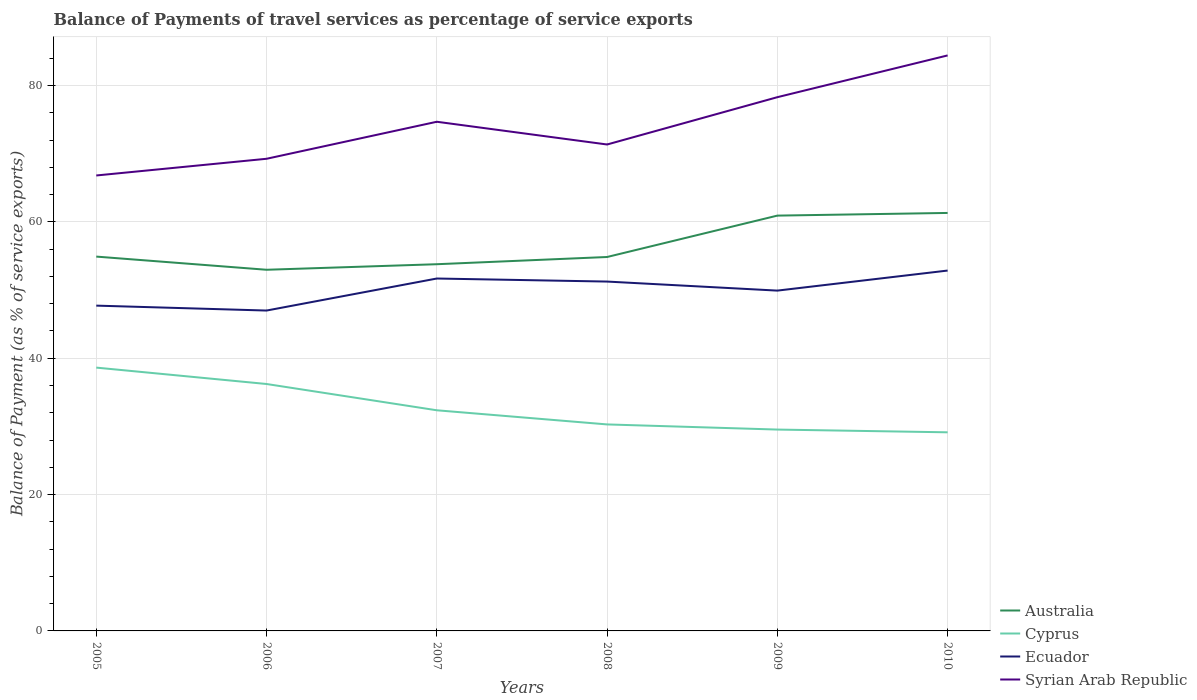Does the line corresponding to Cyprus intersect with the line corresponding to Ecuador?
Offer a very short reply. No. Across all years, what is the maximum balance of payments of travel services in Ecuador?
Make the answer very short. 46.99. What is the total balance of payments of travel services in Ecuador in the graph?
Your answer should be compact. -2.2. What is the difference between the highest and the second highest balance of payments of travel services in Ecuador?
Offer a very short reply. 5.87. What is the difference between the highest and the lowest balance of payments of travel services in Syrian Arab Republic?
Provide a short and direct response. 3. Is the balance of payments of travel services in Ecuador strictly greater than the balance of payments of travel services in Cyprus over the years?
Your answer should be compact. No. How many years are there in the graph?
Give a very brief answer. 6. Are the values on the major ticks of Y-axis written in scientific E-notation?
Offer a very short reply. No. Does the graph contain grids?
Your answer should be compact. Yes. Where does the legend appear in the graph?
Your response must be concise. Bottom right. What is the title of the graph?
Make the answer very short. Balance of Payments of travel services as percentage of service exports. Does "Upper middle income" appear as one of the legend labels in the graph?
Ensure brevity in your answer.  No. What is the label or title of the X-axis?
Your answer should be compact. Years. What is the label or title of the Y-axis?
Your answer should be compact. Balance of Payment (as % of service exports). What is the Balance of Payment (as % of service exports) in Australia in 2005?
Offer a very short reply. 54.91. What is the Balance of Payment (as % of service exports) of Cyprus in 2005?
Offer a very short reply. 38.62. What is the Balance of Payment (as % of service exports) of Ecuador in 2005?
Offer a terse response. 47.71. What is the Balance of Payment (as % of service exports) in Syrian Arab Republic in 2005?
Your answer should be compact. 66.8. What is the Balance of Payment (as % of service exports) of Australia in 2006?
Offer a terse response. 52.97. What is the Balance of Payment (as % of service exports) in Cyprus in 2006?
Give a very brief answer. 36.22. What is the Balance of Payment (as % of service exports) in Ecuador in 2006?
Provide a succinct answer. 46.99. What is the Balance of Payment (as % of service exports) of Syrian Arab Republic in 2006?
Provide a succinct answer. 69.25. What is the Balance of Payment (as % of service exports) of Australia in 2007?
Your answer should be compact. 53.79. What is the Balance of Payment (as % of service exports) of Cyprus in 2007?
Provide a succinct answer. 32.36. What is the Balance of Payment (as % of service exports) in Ecuador in 2007?
Ensure brevity in your answer.  51.69. What is the Balance of Payment (as % of service exports) of Syrian Arab Republic in 2007?
Keep it short and to the point. 74.68. What is the Balance of Payment (as % of service exports) of Australia in 2008?
Provide a short and direct response. 54.85. What is the Balance of Payment (as % of service exports) of Cyprus in 2008?
Your answer should be very brief. 30.29. What is the Balance of Payment (as % of service exports) in Ecuador in 2008?
Make the answer very short. 51.24. What is the Balance of Payment (as % of service exports) of Syrian Arab Republic in 2008?
Your answer should be compact. 71.35. What is the Balance of Payment (as % of service exports) in Australia in 2009?
Make the answer very short. 60.92. What is the Balance of Payment (as % of service exports) of Cyprus in 2009?
Ensure brevity in your answer.  29.53. What is the Balance of Payment (as % of service exports) of Ecuador in 2009?
Make the answer very short. 49.92. What is the Balance of Payment (as % of service exports) of Syrian Arab Republic in 2009?
Provide a short and direct response. 78.29. What is the Balance of Payment (as % of service exports) in Australia in 2010?
Your response must be concise. 61.31. What is the Balance of Payment (as % of service exports) of Cyprus in 2010?
Your answer should be compact. 29.13. What is the Balance of Payment (as % of service exports) in Ecuador in 2010?
Your answer should be compact. 52.86. What is the Balance of Payment (as % of service exports) in Syrian Arab Republic in 2010?
Offer a terse response. 84.41. Across all years, what is the maximum Balance of Payment (as % of service exports) in Australia?
Give a very brief answer. 61.31. Across all years, what is the maximum Balance of Payment (as % of service exports) of Cyprus?
Your response must be concise. 38.62. Across all years, what is the maximum Balance of Payment (as % of service exports) of Ecuador?
Offer a terse response. 52.86. Across all years, what is the maximum Balance of Payment (as % of service exports) in Syrian Arab Republic?
Your answer should be very brief. 84.41. Across all years, what is the minimum Balance of Payment (as % of service exports) of Australia?
Your answer should be compact. 52.97. Across all years, what is the minimum Balance of Payment (as % of service exports) of Cyprus?
Provide a succinct answer. 29.13. Across all years, what is the minimum Balance of Payment (as % of service exports) in Ecuador?
Provide a succinct answer. 46.99. Across all years, what is the minimum Balance of Payment (as % of service exports) of Syrian Arab Republic?
Your answer should be compact. 66.8. What is the total Balance of Payment (as % of service exports) in Australia in the graph?
Ensure brevity in your answer.  338.74. What is the total Balance of Payment (as % of service exports) in Cyprus in the graph?
Keep it short and to the point. 196.16. What is the total Balance of Payment (as % of service exports) of Ecuador in the graph?
Your answer should be compact. 300.41. What is the total Balance of Payment (as % of service exports) of Syrian Arab Republic in the graph?
Offer a very short reply. 444.79. What is the difference between the Balance of Payment (as % of service exports) in Australia in 2005 and that in 2006?
Give a very brief answer. 1.93. What is the difference between the Balance of Payment (as % of service exports) of Cyprus in 2005 and that in 2006?
Keep it short and to the point. 2.4. What is the difference between the Balance of Payment (as % of service exports) of Ecuador in 2005 and that in 2006?
Offer a very short reply. 0.72. What is the difference between the Balance of Payment (as % of service exports) in Syrian Arab Republic in 2005 and that in 2006?
Your answer should be very brief. -2.45. What is the difference between the Balance of Payment (as % of service exports) in Australia in 2005 and that in 2007?
Your response must be concise. 1.12. What is the difference between the Balance of Payment (as % of service exports) of Cyprus in 2005 and that in 2007?
Your response must be concise. 6.26. What is the difference between the Balance of Payment (as % of service exports) in Ecuador in 2005 and that in 2007?
Offer a terse response. -3.98. What is the difference between the Balance of Payment (as % of service exports) of Syrian Arab Republic in 2005 and that in 2007?
Give a very brief answer. -7.88. What is the difference between the Balance of Payment (as % of service exports) of Australia in 2005 and that in 2008?
Your answer should be very brief. 0.06. What is the difference between the Balance of Payment (as % of service exports) in Cyprus in 2005 and that in 2008?
Your answer should be compact. 8.33. What is the difference between the Balance of Payment (as % of service exports) in Ecuador in 2005 and that in 2008?
Make the answer very short. -3.53. What is the difference between the Balance of Payment (as % of service exports) of Syrian Arab Republic in 2005 and that in 2008?
Your answer should be compact. -4.54. What is the difference between the Balance of Payment (as % of service exports) in Australia in 2005 and that in 2009?
Offer a very short reply. -6.01. What is the difference between the Balance of Payment (as % of service exports) of Cyprus in 2005 and that in 2009?
Keep it short and to the point. 9.09. What is the difference between the Balance of Payment (as % of service exports) of Ecuador in 2005 and that in 2009?
Provide a succinct answer. -2.2. What is the difference between the Balance of Payment (as % of service exports) of Syrian Arab Republic in 2005 and that in 2009?
Provide a succinct answer. -11.48. What is the difference between the Balance of Payment (as % of service exports) in Australia in 2005 and that in 2010?
Your response must be concise. -6.41. What is the difference between the Balance of Payment (as % of service exports) of Cyprus in 2005 and that in 2010?
Offer a very short reply. 9.49. What is the difference between the Balance of Payment (as % of service exports) of Ecuador in 2005 and that in 2010?
Ensure brevity in your answer.  -5.14. What is the difference between the Balance of Payment (as % of service exports) in Syrian Arab Republic in 2005 and that in 2010?
Provide a short and direct response. -17.61. What is the difference between the Balance of Payment (as % of service exports) of Australia in 2006 and that in 2007?
Your response must be concise. -0.81. What is the difference between the Balance of Payment (as % of service exports) in Cyprus in 2006 and that in 2007?
Ensure brevity in your answer.  3.85. What is the difference between the Balance of Payment (as % of service exports) of Ecuador in 2006 and that in 2007?
Offer a terse response. -4.7. What is the difference between the Balance of Payment (as % of service exports) in Syrian Arab Republic in 2006 and that in 2007?
Provide a short and direct response. -5.43. What is the difference between the Balance of Payment (as % of service exports) of Australia in 2006 and that in 2008?
Provide a succinct answer. -1.87. What is the difference between the Balance of Payment (as % of service exports) in Cyprus in 2006 and that in 2008?
Provide a short and direct response. 5.93. What is the difference between the Balance of Payment (as % of service exports) of Ecuador in 2006 and that in 2008?
Provide a succinct answer. -4.25. What is the difference between the Balance of Payment (as % of service exports) in Syrian Arab Republic in 2006 and that in 2008?
Ensure brevity in your answer.  -2.09. What is the difference between the Balance of Payment (as % of service exports) of Australia in 2006 and that in 2009?
Make the answer very short. -7.94. What is the difference between the Balance of Payment (as % of service exports) of Cyprus in 2006 and that in 2009?
Offer a very short reply. 6.68. What is the difference between the Balance of Payment (as % of service exports) in Ecuador in 2006 and that in 2009?
Ensure brevity in your answer.  -2.92. What is the difference between the Balance of Payment (as % of service exports) of Syrian Arab Republic in 2006 and that in 2009?
Your answer should be very brief. -9.03. What is the difference between the Balance of Payment (as % of service exports) in Australia in 2006 and that in 2010?
Give a very brief answer. -8.34. What is the difference between the Balance of Payment (as % of service exports) of Cyprus in 2006 and that in 2010?
Make the answer very short. 7.09. What is the difference between the Balance of Payment (as % of service exports) of Ecuador in 2006 and that in 2010?
Your answer should be compact. -5.87. What is the difference between the Balance of Payment (as % of service exports) in Syrian Arab Republic in 2006 and that in 2010?
Give a very brief answer. -15.16. What is the difference between the Balance of Payment (as % of service exports) in Australia in 2007 and that in 2008?
Your answer should be compact. -1.06. What is the difference between the Balance of Payment (as % of service exports) of Cyprus in 2007 and that in 2008?
Provide a short and direct response. 2.07. What is the difference between the Balance of Payment (as % of service exports) of Ecuador in 2007 and that in 2008?
Provide a succinct answer. 0.45. What is the difference between the Balance of Payment (as % of service exports) in Syrian Arab Republic in 2007 and that in 2008?
Provide a succinct answer. 3.33. What is the difference between the Balance of Payment (as % of service exports) in Australia in 2007 and that in 2009?
Make the answer very short. -7.13. What is the difference between the Balance of Payment (as % of service exports) in Cyprus in 2007 and that in 2009?
Offer a very short reply. 2.83. What is the difference between the Balance of Payment (as % of service exports) of Ecuador in 2007 and that in 2009?
Make the answer very short. 1.77. What is the difference between the Balance of Payment (as % of service exports) in Syrian Arab Republic in 2007 and that in 2009?
Your answer should be very brief. -3.6. What is the difference between the Balance of Payment (as % of service exports) in Australia in 2007 and that in 2010?
Provide a succinct answer. -7.52. What is the difference between the Balance of Payment (as % of service exports) of Cyprus in 2007 and that in 2010?
Keep it short and to the point. 3.23. What is the difference between the Balance of Payment (as % of service exports) of Ecuador in 2007 and that in 2010?
Your answer should be very brief. -1.17. What is the difference between the Balance of Payment (as % of service exports) in Syrian Arab Republic in 2007 and that in 2010?
Your answer should be compact. -9.73. What is the difference between the Balance of Payment (as % of service exports) in Australia in 2008 and that in 2009?
Your response must be concise. -6.07. What is the difference between the Balance of Payment (as % of service exports) in Cyprus in 2008 and that in 2009?
Your answer should be compact. 0.75. What is the difference between the Balance of Payment (as % of service exports) of Ecuador in 2008 and that in 2009?
Your response must be concise. 1.33. What is the difference between the Balance of Payment (as % of service exports) of Syrian Arab Republic in 2008 and that in 2009?
Ensure brevity in your answer.  -6.94. What is the difference between the Balance of Payment (as % of service exports) of Australia in 2008 and that in 2010?
Provide a short and direct response. -6.46. What is the difference between the Balance of Payment (as % of service exports) of Cyprus in 2008 and that in 2010?
Your answer should be very brief. 1.16. What is the difference between the Balance of Payment (as % of service exports) of Ecuador in 2008 and that in 2010?
Your response must be concise. -1.61. What is the difference between the Balance of Payment (as % of service exports) of Syrian Arab Republic in 2008 and that in 2010?
Ensure brevity in your answer.  -13.07. What is the difference between the Balance of Payment (as % of service exports) of Australia in 2009 and that in 2010?
Make the answer very short. -0.39. What is the difference between the Balance of Payment (as % of service exports) of Cyprus in 2009 and that in 2010?
Your answer should be very brief. 0.4. What is the difference between the Balance of Payment (as % of service exports) of Ecuador in 2009 and that in 2010?
Offer a very short reply. -2.94. What is the difference between the Balance of Payment (as % of service exports) in Syrian Arab Republic in 2009 and that in 2010?
Offer a very short reply. -6.13. What is the difference between the Balance of Payment (as % of service exports) in Australia in 2005 and the Balance of Payment (as % of service exports) in Cyprus in 2006?
Your response must be concise. 18.69. What is the difference between the Balance of Payment (as % of service exports) of Australia in 2005 and the Balance of Payment (as % of service exports) of Ecuador in 2006?
Keep it short and to the point. 7.91. What is the difference between the Balance of Payment (as % of service exports) in Australia in 2005 and the Balance of Payment (as % of service exports) in Syrian Arab Republic in 2006?
Ensure brevity in your answer.  -14.35. What is the difference between the Balance of Payment (as % of service exports) in Cyprus in 2005 and the Balance of Payment (as % of service exports) in Ecuador in 2006?
Provide a succinct answer. -8.37. What is the difference between the Balance of Payment (as % of service exports) of Cyprus in 2005 and the Balance of Payment (as % of service exports) of Syrian Arab Republic in 2006?
Offer a terse response. -30.63. What is the difference between the Balance of Payment (as % of service exports) in Ecuador in 2005 and the Balance of Payment (as % of service exports) in Syrian Arab Republic in 2006?
Ensure brevity in your answer.  -21.54. What is the difference between the Balance of Payment (as % of service exports) in Australia in 2005 and the Balance of Payment (as % of service exports) in Cyprus in 2007?
Offer a very short reply. 22.54. What is the difference between the Balance of Payment (as % of service exports) in Australia in 2005 and the Balance of Payment (as % of service exports) in Ecuador in 2007?
Give a very brief answer. 3.22. What is the difference between the Balance of Payment (as % of service exports) of Australia in 2005 and the Balance of Payment (as % of service exports) of Syrian Arab Republic in 2007?
Offer a very short reply. -19.78. What is the difference between the Balance of Payment (as % of service exports) of Cyprus in 2005 and the Balance of Payment (as % of service exports) of Ecuador in 2007?
Your response must be concise. -13.07. What is the difference between the Balance of Payment (as % of service exports) of Cyprus in 2005 and the Balance of Payment (as % of service exports) of Syrian Arab Republic in 2007?
Your answer should be very brief. -36.06. What is the difference between the Balance of Payment (as % of service exports) of Ecuador in 2005 and the Balance of Payment (as % of service exports) of Syrian Arab Republic in 2007?
Keep it short and to the point. -26.97. What is the difference between the Balance of Payment (as % of service exports) of Australia in 2005 and the Balance of Payment (as % of service exports) of Cyprus in 2008?
Your answer should be very brief. 24.62. What is the difference between the Balance of Payment (as % of service exports) in Australia in 2005 and the Balance of Payment (as % of service exports) in Ecuador in 2008?
Ensure brevity in your answer.  3.66. What is the difference between the Balance of Payment (as % of service exports) in Australia in 2005 and the Balance of Payment (as % of service exports) in Syrian Arab Republic in 2008?
Your response must be concise. -16.44. What is the difference between the Balance of Payment (as % of service exports) of Cyprus in 2005 and the Balance of Payment (as % of service exports) of Ecuador in 2008?
Your response must be concise. -12.62. What is the difference between the Balance of Payment (as % of service exports) of Cyprus in 2005 and the Balance of Payment (as % of service exports) of Syrian Arab Republic in 2008?
Your response must be concise. -32.73. What is the difference between the Balance of Payment (as % of service exports) in Ecuador in 2005 and the Balance of Payment (as % of service exports) in Syrian Arab Republic in 2008?
Give a very brief answer. -23.63. What is the difference between the Balance of Payment (as % of service exports) in Australia in 2005 and the Balance of Payment (as % of service exports) in Cyprus in 2009?
Keep it short and to the point. 25.37. What is the difference between the Balance of Payment (as % of service exports) of Australia in 2005 and the Balance of Payment (as % of service exports) of Ecuador in 2009?
Your answer should be compact. 4.99. What is the difference between the Balance of Payment (as % of service exports) in Australia in 2005 and the Balance of Payment (as % of service exports) in Syrian Arab Republic in 2009?
Ensure brevity in your answer.  -23.38. What is the difference between the Balance of Payment (as % of service exports) of Cyprus in 2005 and the Balance of Payment (as % of service exports) of Ecuador in 2009?
Provide a short and direct response. -11.29. What is the difference between the Balance of Payment (as % of service exports) of Cyprus in 2005 and the Balance of Payment (as % of service exports) of Syrian Arab Republic in 2009?
Give a very brief answer. -39.67. What is the difference between the Balance of Payment (as % of service exports) in Ecuador in 2005 and the Balance of Payment (as % of service exports) in Syrian Arab Republic in 2009?
Give a very brief answer. -30.57. What is the difference between the Balance of Payment (as % of service exports) of Australia in 2005 and the Balance of Payment (as % of service exports) of Cyprus in 2010?
Provide a succinct answer. 25.77. What is the difference between the Balance of Payment (as % of service exports) in Australia in 2005 and the Balance of Payment (as % of service exports) in Ecuador in 2010?
Ensure brevity in your answer.  2.05. What is the difference between the Balance of Payment (as % of service exports) in Australia in 2005 and the Balance of Payment (as % of service exports) in Syrian Arab Republic in 2010?
Provide a succinct answer. -29.51. What is the difference between the Balance of Payment (as % of service exports) of Cyprus in 2005 and the Balance of Payment (as % of service exports) of Ecuador in 2010?
Offer a terse response. -14.24. What is the difference between the Balance of Payment (as % of service exports) of Cyprus in 2005 and the Balance of Payment (as % of service exports) of Syrian Arab Republic in 2010?
Give a very brief answer. -45.79. What is the difference between the Balance of Payment (as % of service exports) of Ecuador in 2005 and the Balance of Payment (as % of service exports) of Syrian Arab Republic in 2010?
Give a very brief answer. -36.7. What is the difference between the Balance of Payment (as % of service exports) in Australia in 2006 and the Balance of Payment (as % of service exports) in Cyprus in 2007?
Make the answer very short. 20.61. What is the difference between the Balance of Payment (as % of service exports) in Australia in 2006 and the Balance of Payment (as % of service exports) in Ecuador in 2007?
Provide a succinct answer. 1.28. What is the difference between the Balance of Payment (as % of service exports) of Australia in 2006 and the Balance of Payment (as % of service exports) of Syrian Arab Republic in 2007?
Keep it short and to the point. -21.71. What is the difference between the Balance of Payment (as % of service exports) in Cyprus in 2006 and the Balance of Payment (as % of service exports) in Ecuador in 2007?
Offer a terse response. -15.47. What is the difference between the Balance of Payment (as % of service exports) in Cyprus in 2006 and the Balance of Payment (as % of service exports) in Syrian Arab Republic in 2007?
Give a very brief answer. -38.46. What is the difference between the Balance of Payment (as % of service exports) of Ecuador in 2006 and the Balance of Payment (as % of service exports) of Syrian Arab Republic in 2007?
Give a very brief answer. -27.69. What is the difference between the Balance of Payment (as % of service exports) in Australia in 2006 and the Balance of Payment (as % of service exports) in Cyprus in 2008?
Your response must be concise. 22.68. What is the difference between the Balance of Payment (as % of service exports) of Australia in 2006 and the Balance of Payment (as % of service exports) of Ecuador in 2008?
Offer a terse response. 1.73. What is the difference between the Balance of Payment (as % of service exports) in Australia in 2006 and the Balance of Payment (as % of service exports) in Syrian Arab Republic in 2008?
Make the answer very short. -18.37. What is the difference between the Balance of Payment (as % of service exports) in Cyprus in 2006 and the Balance of Payment (as % of service exports) in Ecuador in 2008?
Provide a succinct answer. -15.02. What is the difference between the Balance of Payment (as % of service exports) of Cyprus in 2006 and the Balance of Payment (as % of service exports) of Syrian Arab Republic in 2008?
Your answer should be compact. -35.13. What is the difference between the Balance of Payment (as % of service exports) in Ecuador in 2006 and the Balance of Payment (as % of service exports) in Syrian Arab Republic in 2008?
Provide a succinct answer. -24.36. What is the difference between the Balance of Payment (as % of service exports) of Australia in 2006 and the Balance of Payment (as % of service exports) of Cyprus in 2009?
Provide a short and direct response. 23.44. What is the difference between the Balance of Payment (as % of service exports) in Australia in 2006 and the Balance of Payment (as % of service exports) in Ecuador in 2009?
Make the answer very short. 3.06. What is the difference between the Balance of Payment (as % of service exports) of Australia in 2006 and the Balance of Payment (as % of service exports) of Syrian Arab Republic in 2009?
Your answer should be very brief. -25.31. What is the difference between the Balance of Payment (as % of service exports) in Cyprus in 2006 and the Balance of Payment (as % of service exports) in Ecuador in 2009?
Your response must be concise. -13.7. What is the difference between the Balance of Payment (as % of service exports) in Cyprus in 2006 and the Balance of Payment (as % of service exports) in Syrian Arab Republic in 2009?
Your answer should be compact. -42.07. What is the difference between the Balance of Payment (as % of service exports) of Ecuador in 2006 and the Balance of Payment (as % of service exports) of Syrian Arab Republic in 2009?
Your answer should be compact. -31.3. What is the difference between the Balance of Payment (as % of service exports) in Australia in 2006 and the Balance of Payment (as % of service exports) in Cyprus in 2010?
Your answer should be very brief. 23.84. What is the difference between the Balance of Payment (as % of service exports) in Australia in 2006 and the Balance of Payment (as % of service exports) in Ecuador in 2010?
Your response must be concise. 0.12. What is the difference between the Balance of Payment (as % of service exports) in Australia in 2006 and the Balance of Payment (as % of service exports) in Syrian Arab Republic in 2010?
Keep it short and to the point. -31.44. What is the difference between the Balance of Payment (as % of service exports) of Cyprus in 2006 and the Balance of Payment (as % of service exports) of Ecuador in 2010?
Make the answer very short. -16.64. What is the difference between the Balance of Payment (as % of service exports) in Cyprus in 2006 and the Balance of Payment (as % of service exports) in Syrian Arab Republic in 2010?
Offer a very short reply. -48.2. What is the difference between the Balance of Payment (as % of service exports) of Ecuador in 2006 and the Balance of Payment (as % of service exports) of Syrian Arab Republic in 2010?
Make the answer very short. -37.42. What is the difference between the Balance of Payment (as % of service exports) of Australia in 2007 and the Balance of Payment (as % of service exports) of Cyprus in 2008?
Ensure brevity in your answer.  23.5. What is the difference between the Balance of Payment (as % of service exports) in Australia in 2007 and the Balance of Payment (as % of service exports) in Ecuador in 2008?
Keep it short and to the point. 2.54. What is the difference between the Balance of Payment (as % of service exports) in Australia in 2007 and the Balance of Payment (as % of service exports) in Syrian Arab Republic in 2008?
Offer a terse response. -17.56. What is the difference between the Balance of Payment (as % of service exports) in Cyprus in 2007 and the Balance of Payment (as % of service exports) in Ecuador in 2008?
Keep it short and to the point. -18.88. What is the difference between the Balance of Payment (as % of service exports) in Cyprus in 2007 and the Balance of Payment (as % of service exports) in Syrian Arab Republic in 2008?
Make the answer very short. -38.98. What is the difference between the Balance of Payment (as % of service exports) in Ecuador in 2007 and the Balance of Payment (as % of service exports) in Syrian Arab Republic in 2008?
Make the answer very short. -19.66. What is the difference between the Balance of Payment (as % of service exports) of Australia in 2007 and the Balance of Payment (as % of service exports) of Cyprus in 2009?
Give a very brief answer. 24.25. What is the difference between the Balance of Payment (as % of service exports) of Australia in 2007 and the Balance of Payment (as % of service exports) of Ecuador in 2009?
Provide a succinct answer. 3.87. What is the difference between the Balance of Payment (as % of service exports) of Australia in 2007 and the Balance of Payment (as % of service exports) of Syrian Arab Republic in 2009?
Keep it short and to the point. -24.5. What is the difference between the Balance of Payment (as % of service exports) in Cyprus in 2007 and the Balance of Payment (as % of service exports) in Ecuador in 2009?
Your answer should be very brief. -17.55. What is the difference between the Balance of Payment (as % of service exports) in Cyprus in 2007 and the Balance of Payment (as % of service exports) in Syrian Arab Republic in 2009?
Offer a very short reply. -45.92. What is the difference between the Balance of Payment (as % of service exports) of Ecuador in 2007 and the Balance of Payment (as % of service exports) of Syrian Arab Republic in 2009?
Your answer should be very brief. -26.6. What is the difference between the Balance of Payment (as % of service exports) of Australia in 2007 and the Balance of Payment (as % of service exports) of Cyprus in 2010?
Offer a very short reply. 24.66. What is the difference between the Balance of Payment (as % of service exports) of Australia in 2007 and the Balance of Payment (as % of service exports) of Ecuador in 2010?
Offer a very short reply. 0.93. What is the difference between the Balance of Payment (as % of service exports) in Australia in 2007 and the Balance of Payment (as % of service exports) in Syrian Arab Republic in 2010?
Provide a short and direct response. -30.63. What is the difference between the Balance of Payment (as % of service exports) in Cyprus in 2007 and the Balance of Payment (as % of service exports) in Ecuador in 2010?
Offer a terse response. -20.49. What is the difference between the Balance of Payment (as % of service exports) in Cyprus in 2007 and the Balance of Payment (as % of service exports) in Syrian Arab Republic in 2010?
Your response must be concise. -52.05. What is the difference between the Balance of Payment (as % of service exports) in Ecuador in 2007 and the Balance of Payment (as % of service exports) in Syrian Arab Republic in 2010?
Provide a succinct answer. -32.72. What is the difference between the Balance of Payment (as % of service exports) of Australia in 2008 and the Balance of Payment (as % of service exports) of Cyprus in 2009?
Your answer should be very brief. 25.31. What is the difference between the Balance of Payment (as % of service exports) in Australia in 2008 and the Balance of Payment (as % of service exports) in Ecuador in 2009?
Keep it short and to the point. 4.93. What is the difference between the Balance of Payment (as % of service exports) in Australia in 2008 and the Balance of Payment (as % of service exports) in Syrian Arab Republic in 2009?
Give a very brief answer. -23.44. What is the difference between the Balance of Payment (as % of service exports) of Cyprus in 2008 and the Balance of Payment (as % of service exports) of Ecuador in 2009?
Provide a succinct answer. -19.63. What is the difference between the Balance of Payment (as % of service exports) in Cyprus in 2008 and the Balance of Payment (as % of service exports) in Syrian Arab Republic in 2009?
Your answer should be very brief. -48. What is the difference between the Balance of Payment (as % of service exports) of Ecuador in 2008 and the Balance of Payment (as % of service exports) of Syrian Arab Republic in 2009?
Offer a terse response. -27.04. What is the difference between the Balance of Payment (as % of service exports) in Australia in 2008 and the Balance of Payment (as % of service exports) in Cyprus in 2010?
Your answer should be compact. 25.71. What is the difference between the Balance of Payment (as % of service exports) of Australia in 2008 and the Balance of Payment (as % of service exports) of Ecuador in 2010?
Your response must be concise. 1.99. What is the difference between the Balance of Payment (as % of service exports) of Australia in 2008 and the Balance of Payment (as % of service exports) of Syrian Arab Republic in 2010?
Offer a very short reply. -29.57. What is the difference between the Balance of Payment (as % of service exports) in Cyprus in 2008 and the Balance of Payment (as % of service exports) in Ecuador in 2010?
Provide a short and direct response. -22.57. What is the difference between the Balance of Payment (as % of service exports) in Cyprus in 2008 and the Balance of Payment (as % of service exports) in Syrian Arab Republic in 2010?
Your answer should be compact. -54.12. What is the difference between the Balance of Payment (as % of service exports) of Ecuador in 2008 and the Balance of Payment (as % of service exports) of Syrian Arab Republic in 2010?
Your answer should be very brief. -33.17. What is the difference between the Balance of Payment (as % of service exports) of Australia in 2009 and the Balance of Payment (as % of service exports) of Cyprus in 2010?
Offer a terse response. 31.79. What is the difference between the Balance of Payment (as % of service exports) of Australia in 2009 and the Balance of Payment (as % of service exports) of Ecuador in 2010?
Offer a very short reply. 8.06. What is the difference between the Balance of Payment (as % of service exports) in Australia in 2009 and the Balance of Payment (as % of service exports) in Syrian Arab Republic in 2010?
Your response must be concise. -23.5. What is the difference between the Balance of Payment (as % of service exports) in Cyprus in 2009 and the Balance of Payment (as % of service exports) in Ecuador in 2010?
Your answer should be compact. -23.32. What is the difference between the Balance of Payment (as % of service exports) in Cyprus in 2009 and the Balance of Payment (as % of service exports) in Syrian Arab Republic in 2010?
Your response must be concise. -54.88. What is the difference between the Balance of Payment (as % of service exports) in Ecuador in 2009 and the Balance of Payment (as % of service exports) in Syrian Arab Republic in 2010?
Keep it short and to the point. -34.5. What is the average Balance of Payment (as % of service exports) of Australia per year?
Give a very brief answer. 56.46. What is the average Balance of Payment (as % of service exports) of Cyprus per year?
Ensure brevity in your answer.  32.69. What is the average Balance of Payment (as % of service exports) of Ecuador per year?
Ensure brevity in your answer.  50.07. What is the average Balance of Payment (as % of service exports) in Syrian Arab Republic per year?
Keep it short and to the point. 74.13. In the year 2005, what is the difference between the Balance of Payment (as % of service exports) of Australia and Balance of Payment (as % of service exports) of Cyprus?
Keep it short and to the point. 16.28. In the year 2005, what is the difference between the Balance of Payment (as % of service exports) of Australia and Balance of Payment (as % of service exports) of Ecuador?
Provide a succinct answer. 7.19. In the year 2005, what is the difference between the Balance of Payment (as % of service exports) of Australia and Balance of Payment (as % of service exports) of Syrian Arab Republic?
Provide a succinct answer. -11.9. In the year 2005, what is the difference between the Balance of Payment (as % of service exports) of Cyprus and Balance of Payment (as % of service exports) of Ecuador?
Keep it short and to the point. -9.09. In the year 2005, what is the difference between the Balance of Payment (as % of service exports) of Cyprus and Balance of Payment (as % of service exports) of Syrian Arab Republic?
Give a very brief answer. -28.18. In the year 2005, what is the difference between the Balance of Payment (as % of service exports) of Ecuador and Balance of Payment (as % of service exports) of Syrian Arab Republic?
Offer a terse response. -19.09. In the year 2006, what is the difference between the Balance of Payment (as % of service exports) in Australia and Balance of Payment (as % of service exports) in Cyprus?
Your response must be concise. 16.75. In the year 2006, what is the difference between the Balance of Payment (as % of service exports) in Australia and Balance of Payment (as % of service exports) in Ecuador?
Make the answer very short. 5.98. In the year 2006, what is the difference between the Balance of Payment (as % of service exports) in Australia and Balance of Payment (as % of service exports) in Syrian Arab Republic?
Offer a terse response. -16.28. In the year 2006, what is the difference between the Balance of Payment (as % of service exports) of Cyprus and Balance of Payment (as % of service exports) of Ecuador?
Offer a terse response. -10.77. In the year 2006, what is the difference between the Balance of Payment (as % of service exports) of Cyprus and Balance of Payment (as % of service exports) of Syrian Arab Republic?
Your answer should be very brief. -33.04. In the year 2006, what is the difference between the Balance of Payment (as % of service exports) of Ecuador and Balance of Payment (as % of service exports) of Syrian Arab Republic?
Offer a terse response. -22.26. In the year 2007, what is the difference between the Balance of Payment (as % of service exports) in Australia and Balance of Payment (as % of service exports) in Cyprus?
Offer a terse response. 21.42. In the year 2007, what is the difference between the Balance of Payment (as % of service exports) in Australia and Balance of Payment (as % of service exports) in Ecuador?
Ensure brevity in your answer.  2.1. In the year 2007, what is the difference between the Balance of Payment (as % of service exports) of Australia and Balance of Payment (as % of service exports) of Syrian Arab Republic?
Give a very brief answer. -20.9. In the year 2007, what is the difference between the Balance of Payment (as % of service exports) in Cyprus and Balance of Payment (as % of service exports) in Ecuador?
Offer a terse response. -19.33. In the year 2007, what is the difference between the Balance of Payment (as % of service exports) of Cyprus and Balance of Payment (as % of service exports) of Syrian Arab Republic?
Your answer should be very brief. -42.32. In the year 2007, what is the difference between the Balance of Payment (as % of service exports) of Ecuador and Balance of Payment (as % of service exports) of Syrian Arab Republic?
Provide a succinct answer. -22.99. In the year 2008, what is the difference between the Balance of Payment (as % of service exports) in Australia and Balance of Payment (as % of service exports) in Cyprus?
Your answer should be compact. 24.56. In the year 2008, what is the difference between the Balance of Payment (as % of service exports) of Australia and Balance of Payment (as % of service exports) of Ecuador?
Provide a short and direct response. 3.6. In the year 2008, what is the difference between the Balance of Payment (as % of service exports) of Australia and Balance of Payment (as % of service exports) of Syrian Arab Republic?
Offer a very short reply. -16.5. In the year 2008, what is the difference between the Balance of Payment (as % of service exports) of Cyprus and Balance of Payment (as % of service exports) of Ecuador?
Offer a very short reply. -20.95. In the year 2008, what is the difference between the Balance of Payment (as % of service exports) of Cyprus and Balance of Payment (as % of service exports) of Syrian Arab Republic?
Ensure brevity in your answer.  -41.06. In the year 2008, what is the difference between the Balance of Payment (as % of service exports) in Ecuador and Balance of Payment (as % of service exports) in Syrian Arab Republic?
Provide a succinct answer. -20.1. In the year 2009, what is the difference between the Balance of Payment (as % of service exports) in Australia and Balance of Payment (as % of service exports) in Cyprus?
Offer a terse response. 31.38. In the year 2009, what is the difference between the Balance of Payment (as % of service exports) of Australia and Balance of Payment (as % of service exports) of Ecuador?
Offer a terse response. 11. In the year 2009, what is the difference between the Balance of Payment (as % of service exports) in Australia and Balance of Payment (as % of service exports) in Syrian Arab Republic?
Ensure brevity in your answer.  -17.37. In the year 2009, what is the difference between the Balance of Payment (as % of service exports) in Cyprus and Balance of Payment (as % of service exports) in Ecuador?
Keep it short and to the point. -20.38. In the year 2009, what is the difference between the Balance of Payment (as % of service exports) of Cyprus and Balance of Payment (as % of service exports) of Syrian Arab Republic?
Your answer should be very brief. -48.75. In the year 2009, what is the difference between the Balance of Payment (as % of service exports) of Ecuador and Balance of Payment (as % of service exports) of Syrian Arab Republic?
Give a very brief answer. -28.37. In the year 2010, what is the difference between the Balance of Payment (as % of service exports) of Australia and Balance of Payment (as % of service exports) of Cyprus?
Keep it short and to the point. 32.18. In the year 2010, what is the difference between the Balance of Payment (as % of service exports) in Australia and Balance of Payment (as % of service exports) in Ecuador?
Provide a short and direct response. 8.45. In the year 2010, what is the difference between the Balance of Payment (as % of service exports) of Australia and Balance of Payment (as % of service exports) of Syrian Arab Republic?
Your response must be concise. -23.1. In the year 2010, what is the difference between the Balance of Payment (as % of service exports) of Cyprus and Balance of Payment (as % of service exports) of Ecuador?
Provide a succinct answer. -23.73. In the year 2010, what is the difference between the Balance of Payment (as % of service exports) of Cyprus and Balance of Payment (as % of service exports) of Syrian Arab Republic?
Your answer should be very brief. -55.28. In the year 2010, what is the difference between the Balance of Payment (as % of service exports) of Ecuador and Balance of Payment (as % of service exports) of Syrian Arab Republic?
Your answer should be very brief. -31.56. What is the ratio of the Balance of Payment (as % of service exports) of Australia in 2005 to that in 2006?
Keep it short and to the point. 1.04. What is the ratio of the Balance of Payment (as % of service exports) in Cyprus in 2005 to that in 2006?
Offer a terse response. 1.07. What is the ratio of the Balance of Payment (as % of service exports) of Ecuador in 2005 to that in 2006?
Make the answer very short. 1.02. What is the ratio of the Balance of Payment (as % of service exports) of Syrian Arab Republic in 2005 to that in 2006?
Ensure brevity in your answer.  0.96. What is the ratio of the Balance of Payment (as % of service exports) of Australia in 2005 to that in 2007?
Offer a terse response. 1.02. What is the ratio of the Balance of Payment (as % of service exports) in Cyprus in 2005 to that in 2007?
Give a very brief answer. 1.19. What is the ratio of the Balance of Payment (as % of service exports) in Ecuador in 2005 to that in 2007?
Give a very brief answer. 0.92. What is the ratio of the Balance of Payment (as % of service exports) of Syrian Arab Republic in 2005 to that in 2007?
Keep it short and to the point. 0.89. What is the ratio of the Balance of Payment (as % of service exports) in Cyprus in 2005 to that in 2008?
Provide a succinct answer. 1.28. What is the ratio of the Balance of Payment (as % of service exports) of Ecuador in 2005 to that in 2008?
Give a very brief answer. 0.93. What is the ratio of the Balance of Payment (as % of service exports) of Syrian Arab Republic in 2005 to that in 2008?
Your answer should be compact. 0.94. What is the ratio of the Balance of Payment (as % of service exports) of Australia in 2005 to that in 2009?
Offer a terse response. 0.9. What is the ratio of the Balance of Payment (as % of service exports) in Cyprus in 2005 to that in 2009?
Offer a terse response. 1.31. What is the ratio of the Balance of Payment (as % of service exports) of Ecuador in 2005 to that in 2009?
Your answer should be compact. 0.96. What is the ratio of the Balance of Payment (as % of service exports) of Syrian Arab Republic in 2005 to that in 2009?
Offer a very short reply. 0.85. What is the ratio of the Balance of Payment (as % of service exports) in Australia in 2005 to that in 2010?
Offer a very short reply. 0.9. What is the ratio of the Balance of Payment (as % of service exports) in Cyprus in 2005 to that in 2010?
Your answer should be very brief. 1.33. What is the ratio of the Balance of Payment (as % of service exports) in Ecuador in 2005 to that in 2010?
Your answer should be compact. 0.9. What is the ratio of the Balance of Payment (as % of service exports) in Syrian Arab Republic in 2005 to that in 2010?
Give a very brief answer. 0.79. What is the ratio of the Balance of Payment (as % of service exports) in Australia in 2006 to that in 2007?
Ensure brevity in your answer.  0.98. What is the ratio of the Balance of Payment (as % of service exports) in Cyprus in 2006 to that in 2007?
Offer a terse response. 1.12. What is the ratio of the Balance of Payment (as % of service exports) of Syrian Arab Republic in 2006 to that in 2007?
Give a very brief answer. 0.93. What is the ratio of the Balance of Payment (as % of service exports) in Australia in 2006 to that in 2008?
Provide a short and direct response. 0.97. What is the ratio of the Balance of Payment (as % of service exports) in Cyprus in 2006 to that in 2008?
Offer a terse response. 1.2. What is the ratio of the Balance of Payment (as % of service exports) in Ecuador in 2006 to that in 2008?
Provide a succinct answer. 0.92. What is the ratio of the Balance of Payment (as % of service exports) of Syrian Arab Republic in 2006 to that in 2008?
Your answer should be compact. 0.97. What is the ratio of the Balance of Payment (as % of service exports) of Australia in 2006 to that in 2009?
Offer a very short reply. 0.87. What is the ratio of the Balance of Payment (as % of service exports) in Cyprus in 2006 to that in 2009?
Provide a succinct answer. 1.23. What is the ratio of the Balance of Payment (as % of service exports) in Ecuador in 2006 to that in 2009?
Provide a succinct answer. 0.94. What is the ratio of the Balance of Payment (as % of service exports) of Syrian Arab Republic in 2006 to that in 2009?
Make the answer very short. 0.88. What is the ratio of the Balance of Payment (as % of service exports) in Australia in 2006 to that in 2010?
Provide a succinct answer. 0.86. What is the ratio of the Balance of Payment (as % of service exports) in Cyprus in 2006 to that in 2010?
Keep it short and to the point. 1.24. What is the ratio of the Balance of Payment (as % of service exports) in Ecuador in 2006 to that in 2010?
Offer a terse response. 0.89. What is the ratio of the Balance of Payment (as % of service exports) of Syrian Arab Republic in 2006 to that in 2010?
Ensure brevity in your answer.  0.82. What is the ratio of the Balance of Payment (as % of service exports) in Australia in 2007 to that in 2008?
Give a very brief answer. 0.98. What is the ratio of the Balance of Payment (as % of service exports) in Cyprus in 2007 to that in 2008?
Keep it short and to the point. 1.07. What is the ratio of the Balance of Payment (as % of service exports) of Ecuador in 2007 to that in 2008?
Ensure brevity in your answer.  1.01. What is the ratio of the Balance of Payment (as % of service exports) in Syrian Arab Republic in 2007 to that in 2008?
Make the answer very short. 1.05. What is the ratio of the Balance of Payment (as % of service exports) in Australia in 2007 to that in 2009?
Your answer should be very brief. 0.88. What is the ratio of the Balance of Payment (as % of service exports) in Cyprus in 2007 to that in 2009?
Offer a very short reply. 1.1. What is the ratio of the Balance of Payment (as % of service exports) in Ecuador in 2007 to that in 2009?
Your answer should be compact. 1.04. What is the ratio of the Balance of Payment (as % of service exports) of Syrian Arab Republic in 2007 to that in 2009?
Your answer should be very brief. 0.95. What is the ratio of the Balance of Payment (as % of service exports) in Australia in 2007 to that in 2010?
Keep it short and to the point. 0.88. What is the ratio of the Balance of Payment (as % of service exports) of Cyprus in 2007 to that in 2010?
Give a very brief answer. 1.11. What is the ratio of the Balance of Payment (as % of service exports) of Ecuador in 2007 to that in 2010?
Your response must be concise. 0.98. What is the ratio of the Balance of Payment (as % of service exports) of Syrian Arab Republic in 2007 to that in 2010?
Your response must be concise. 0.88. What is the ratio of the Balance of Payment (as % of service exports) in Australia in 2008 to that in 2009?
Your response must be concise. 0.9. What is the ratio of the Balance of Payment (as % of service exports) of Cyprus in 2008 to that in 2009?
Offer a terse response. 1.03. What is the ratio of the Balance of Payment (as % of service exports) of Ecuador in 2008 to that in 2009?
Your answer should be very brief. 1.03. What is the ratio of the Balance of Payment (as % of service exports) in Syrian Arab Republic in 2008 to that in 2009?
Make the answer very short. 0.91. What is the ratio of the Balance of Payment (as % of service exports) in Australia in 2008 to that in 2010?
Keep it short and to the point. 0.89. What is the ratio of the Balance of Payment (as % of service exports) in Cyprus in 2008 to that in 2010?
Offer a very short reply. 1.04. What is the ratio of the Balance of Payment (as % of service exports) in Ecuador in 2008 to that in 2010?
Provide a succinct answer. 0.97. What is the ratio of the Balance of Payment (as % of service exports) in Syrian Arab Republic in 2008 to that in 2010?
Provide a succinct answer. 0.85. What is the ratio of the Balance of Payment (as % of service exports) in Cyprus in 2009 to that in 2010?
Provide a succinct answer. 1.01. What is the ratio of the Balance of Payment (as % of service exports) of Ecuador in 2009 to that in 2010?
Give a very brief answer. 0.94. What is the ratio of the Balance of Payment (as % of service exports) in Syrian Arab Republic in 2009 to that in 2010?
Ensure brevity in your answer.  0.93. What is the difference between the highest and the second highest Balance of Payment (as % of service exports) in Australia?
Give a very brief answer. 0.39. What is the difference between the highest and the second highest Balance of Payment (as % of service exports) in Cyprus?
Keep it short and to the point. 2.4. What is the difference between the highest and the second highest Balance of Payment (as % of service exports) of Ecuador?
Your answer should be compact. 1.17. What is the difference between the highest and the second highest Balance of Payment (as % of service exports) in Syrian Arab Republic?
Your answer should be very brief. 6.13. What is the difference between the highest and the lowest Balance of Payment (as % of service exports) of Australia?
Your answer should be compact. 8.34. What is the difference between the highest and the lowest Balance of Payment (as % of service exports) of Cyprus?
Provide a succinct answer. 9.49. What is the difference between the highest and the lowest Balance of Payment (as % of service exports) in Ecuador?
Provide a succinct answer. 5.87. What is the difference between the highest and the lowest Balance of Payment (as % of service exports) in Syrian Arab Republic?
Offer a very short reply. 17.61. 